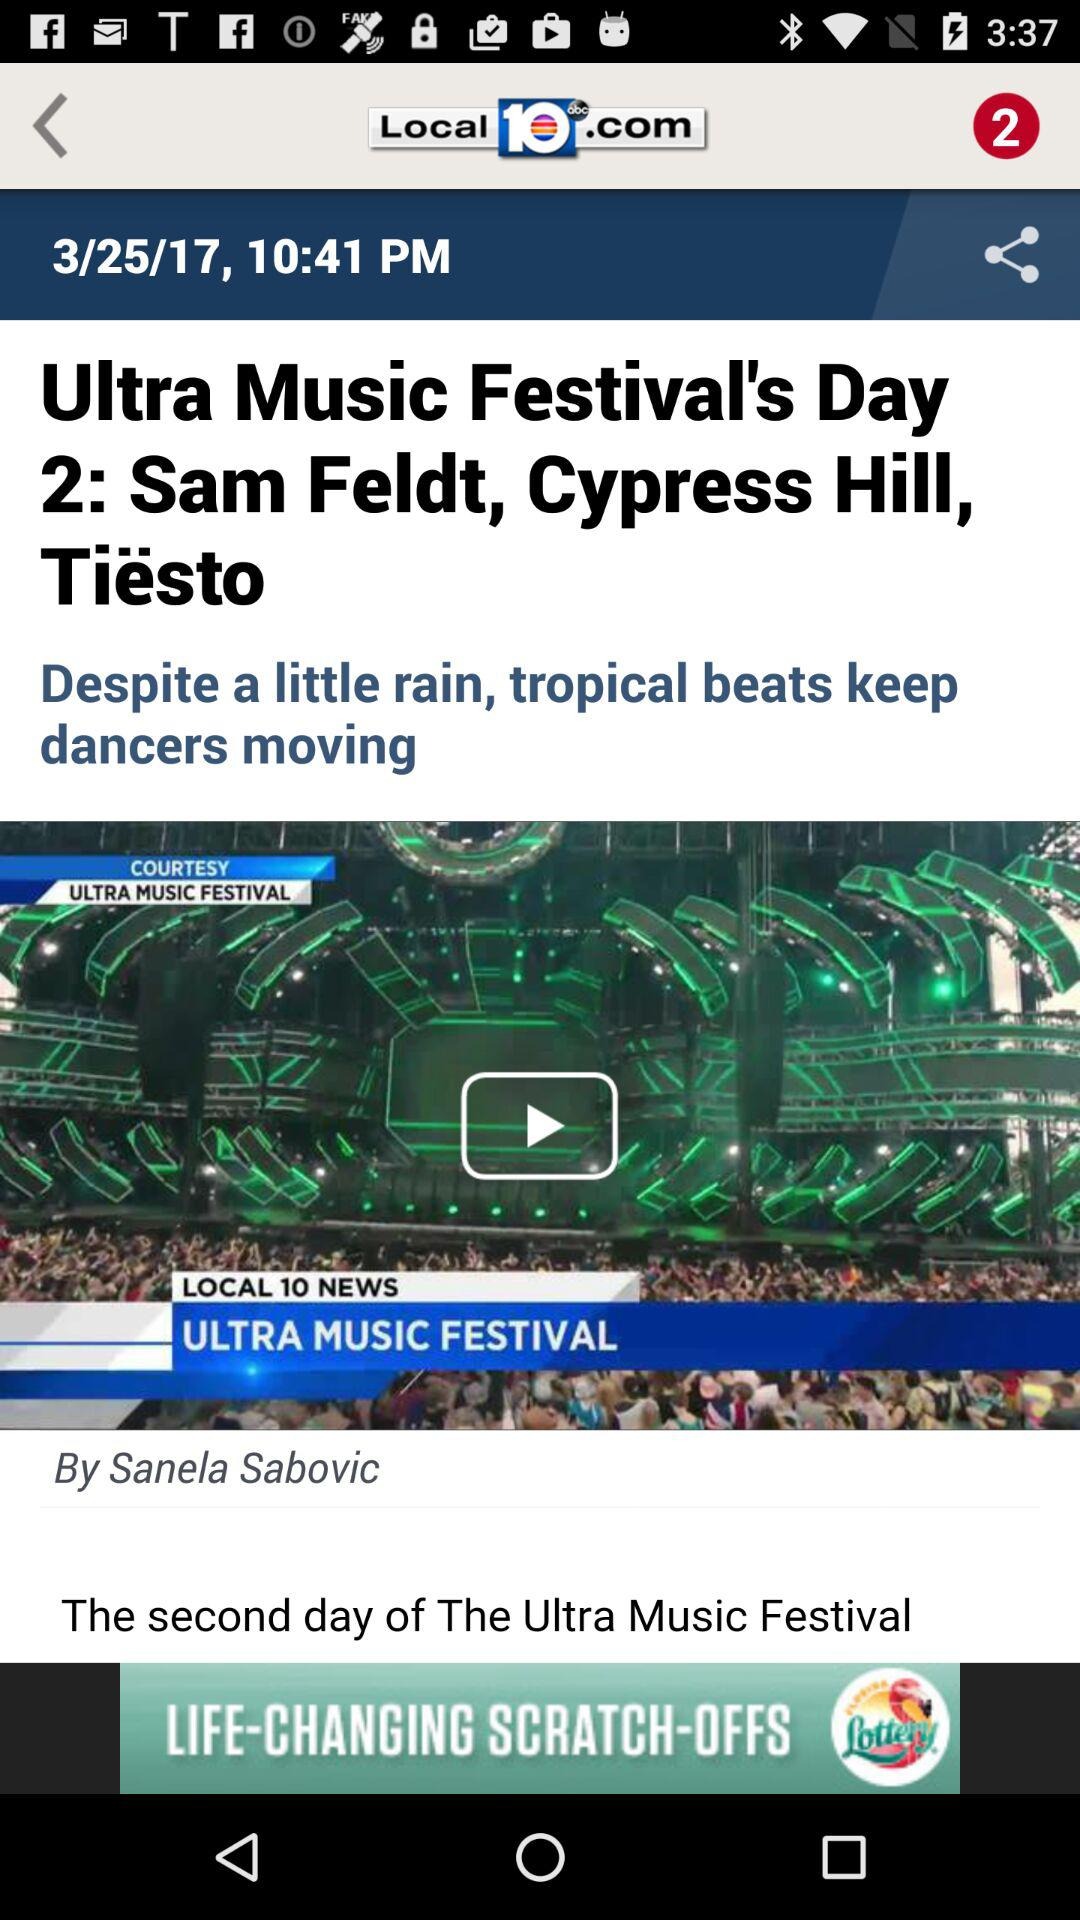What is the publication date of the content? The publication date is March 25, 2017. 